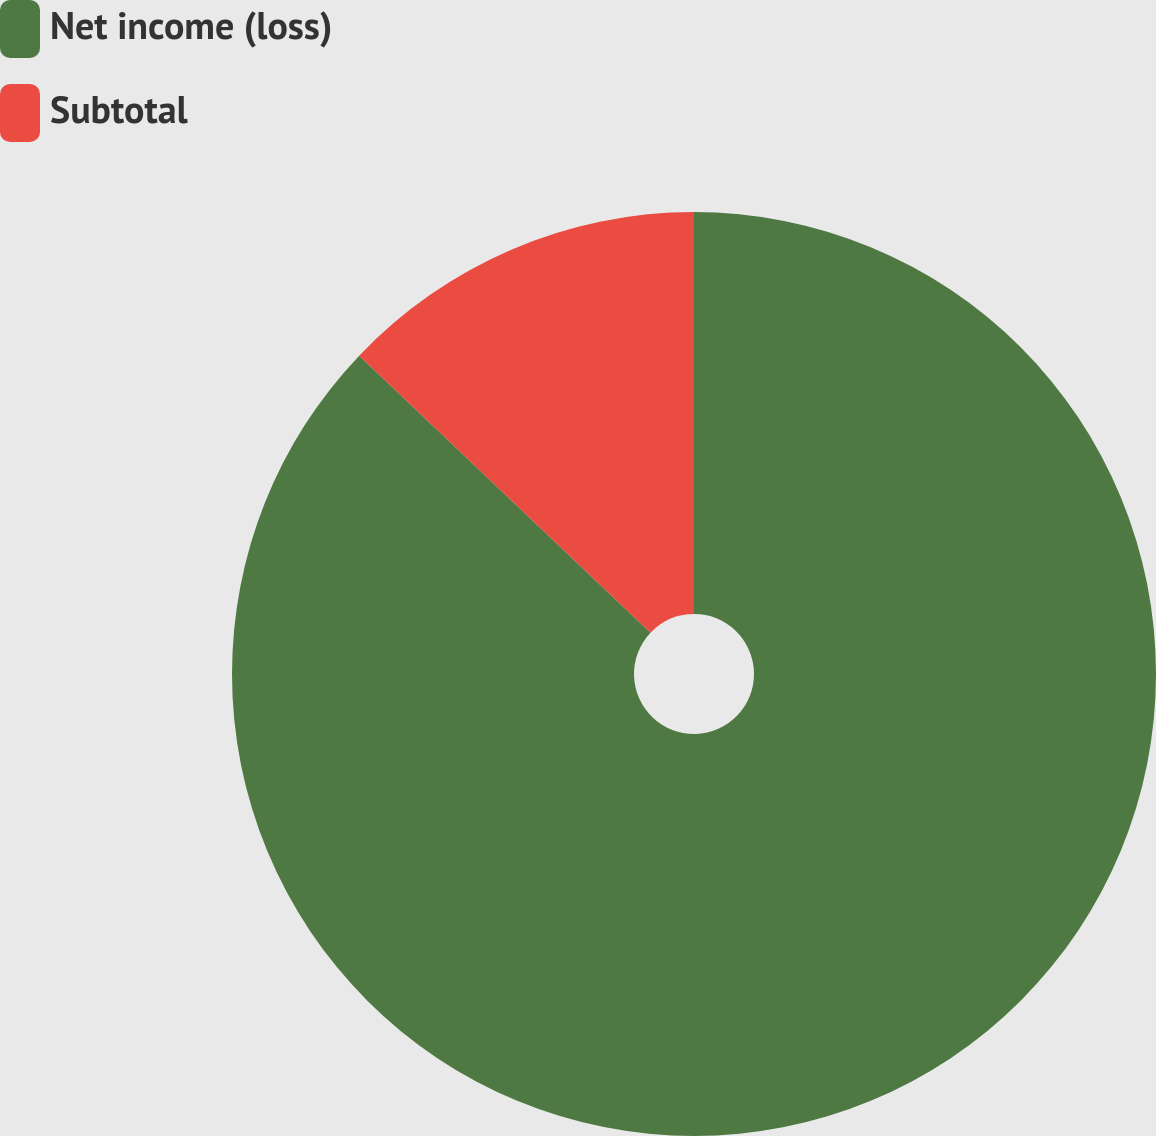<chart> <loc_0><loc_0><loc_500><loc_500><pie_chart><fcel>Net income (loss)<fcel>Subtotal<nl><fcel>87.1%<fcel>12.9%<nl></chart> 